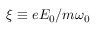Convert formula to latex. <formula><loc_0><loc_0><loc_500><loc_500>\xi \equiv e E _ { 0 } / m \omega _ { 0 }</formula> 